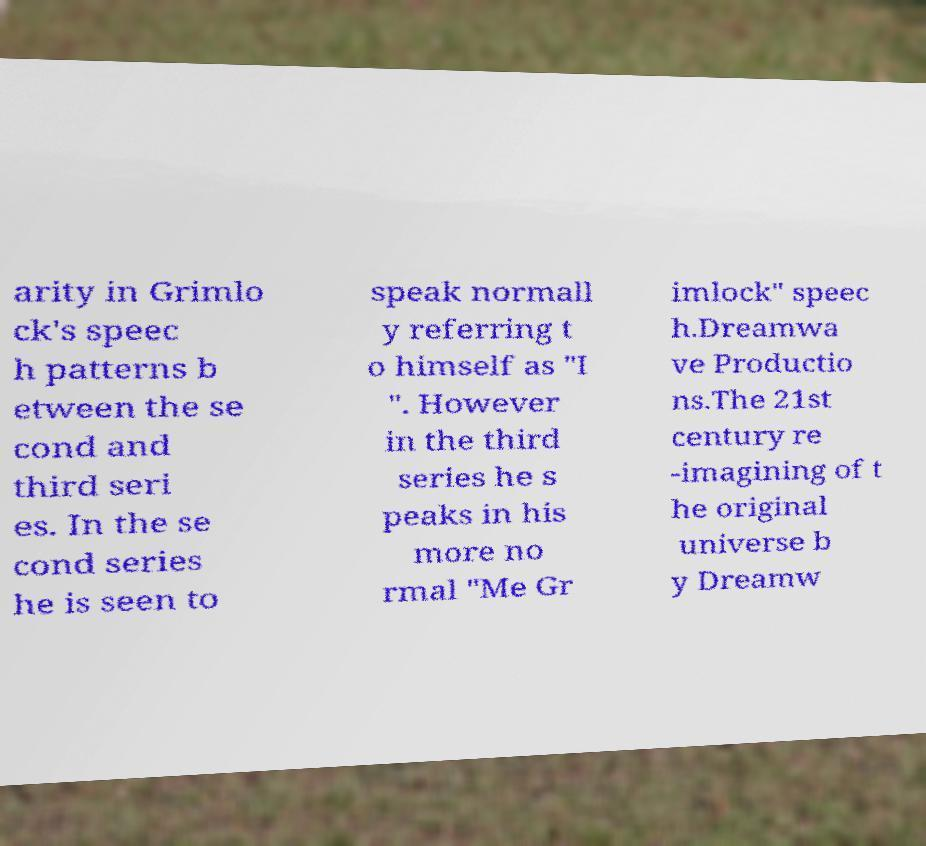I need the written content from this picture converted into text. Can you do that? arity in Grimlo ck's speec h patterns b etween the se cond and third seri es. In the se cond series he is seen to speak normall y referring t o himself as "I ". However in the third series he s peaks in his more no rmal "Me Gr imlock" speec h.Dreamwa ve Productio ns.The 21st century re -imagining of t he original universe b y Dreamw 